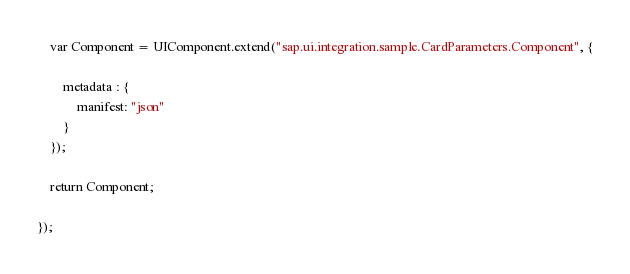<code> <loc_0><loc_0><loc_500><loc_500><_JavaScript_>
	var Component = UIComponent.extend("sap.ui.integration.sample.CardParameters.Component", {

		metadata : {
		    manifest: "json"
		}
	});

	return Component;

});
</code> 